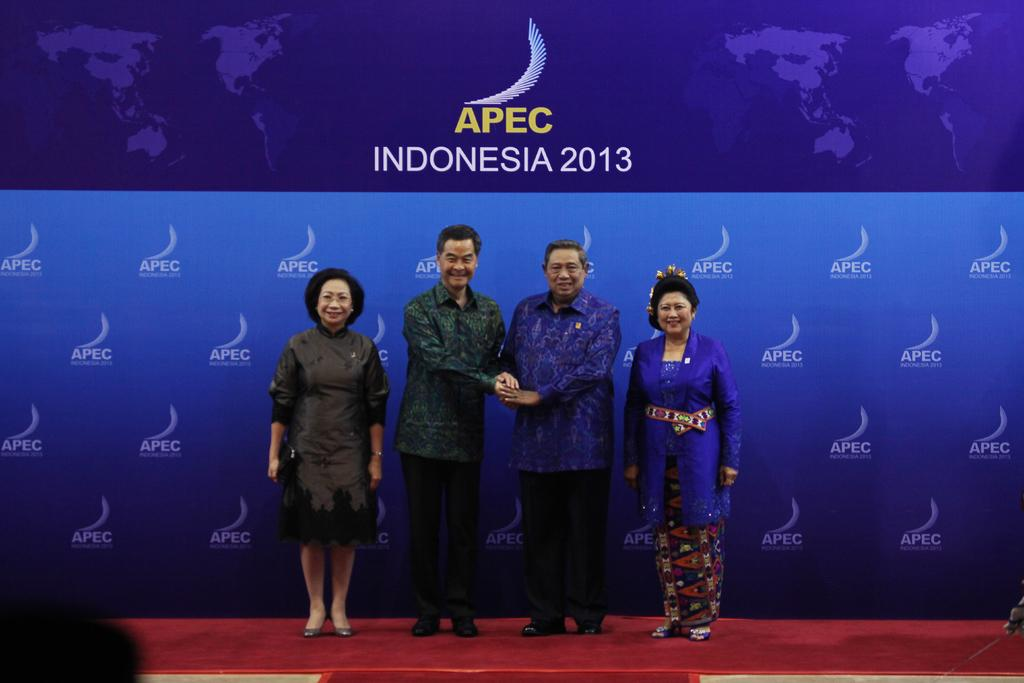What is happening in the middle of the image? There are people standing in the middle of the image. What is the facial expression of the people in the image? The people are smiling. What can be seen behind the people in the image? There is a banner behind the people. What is the limit of disgust that the people in the image are expressing? There is no indication of disgust in the image; the people are smiling. 